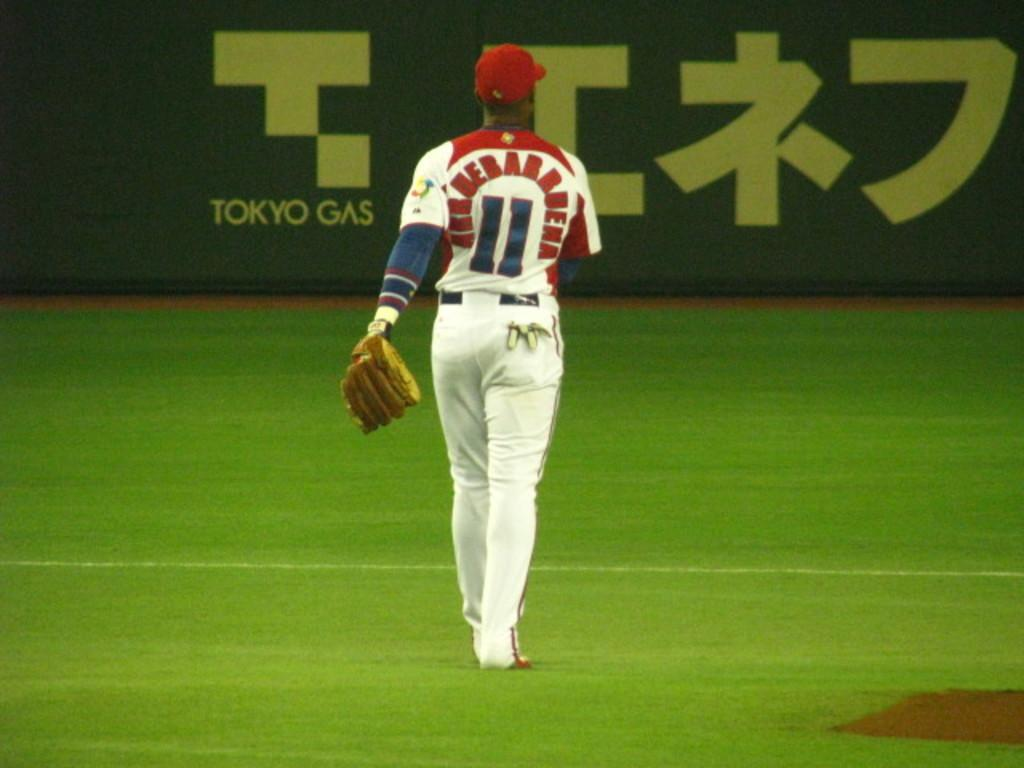<image>
Create a compact narrative representing the image presented. A baseball player with the number 11 on his jersey is walking the field. 